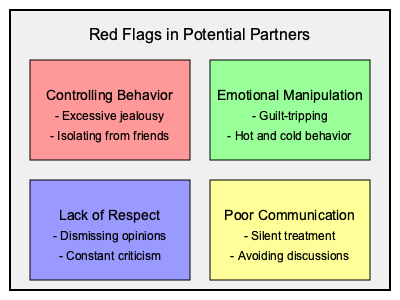Based on the visual cues provided in the image, which category of red flags includes "hot and cold behavior" as an example? To answer this question, we need to carefully examine the information presented in the image. Let's break it down step-by-step:

1. The image shows four categories of red flags in potential partners.
2. Each category is represented by a colored rectangle containing a main title and two examples.
3. The four categories are:
   a. Controlling Behavior (red rectangle)
   b. Emotional Manipulation (green rectangle)
   c. Lack of Respect (blue rectangle)
   d. Poor Communication (yellow rectangle)
4. We need to find which category lists "hot and cold behavior" as an example.
5. Scanning through the examples in each category, we can see that "hot and cold behavior" is listed under the green rectangle.
6. The green rectangle is labeled "Emotional Manipulation."

Therefore, the category that includes "hot and cold behavior" as an example is Emotional Manipulation.
Answer: Emotional Manipulation 